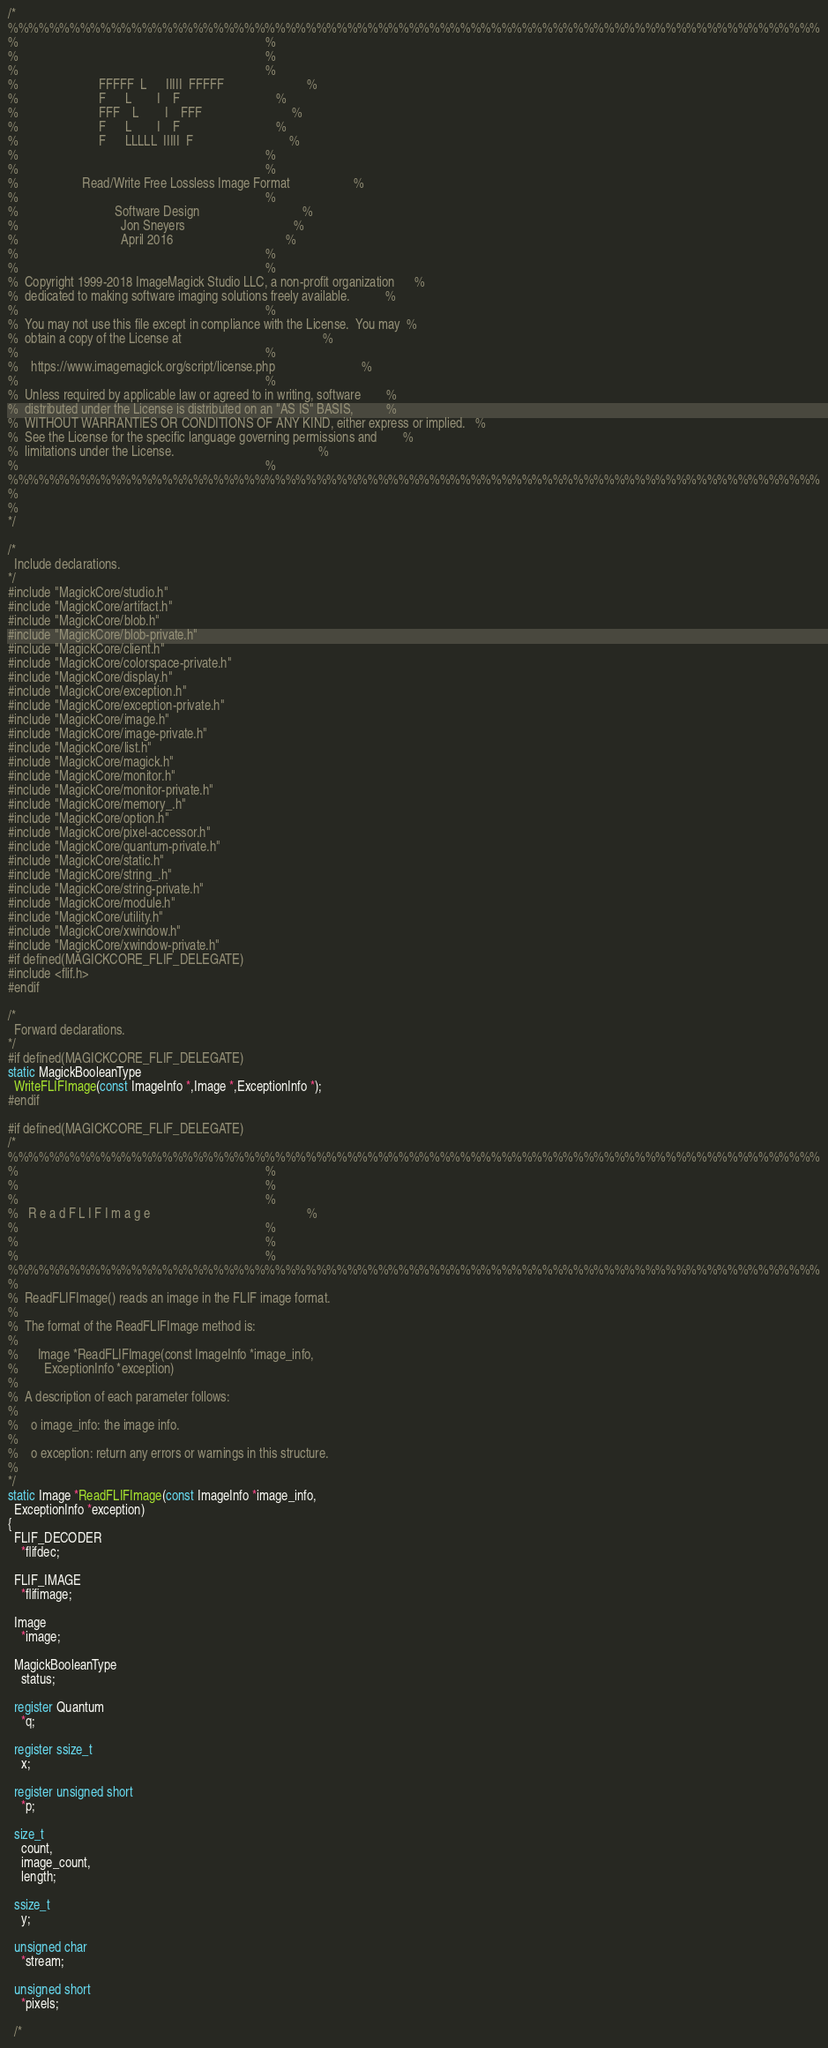<code> <loc_0><loc_0><loc_500><loc_500><_C_>/*
%%%%%%%%%%%%%%%%%%%%%%%%%%%%%%%%%%%%%%%%%%%%%%%%%%%%%%%%%%%%%%%%%%%%%%%%%%%%%%%
%                                                                             %
%                                                                             %
%                                                                             %
%                         FFFFF  L      IIIII  FFFFF                          %
%                         F      L        I    F                              %
%                         FFF    L        I    FFF                            %
%                         F      L        I    F                              %
%                         F      LLLLL  IIIII  F                              %
%                                                                             %
%                                                                             %
%                    Read/Write Free Lossless Image Format                    %
%                                                                             %
%                              Software Design                                %
%                                Jon Sneyers                                  %
%                                April 2016                                   %
%                                                                             %
%                                                                             %
%  Copyright 1999-2018 ImageMagick Studio LLC, a non-profit organization      %
%  dedicated to making software imaging solutions freely available.           %
%                                                                             %
%  You may not use this file except in compliance with the License.  You may  %
%  obtain a copy of the License at                                            %
%                                                                             %
%    https://www.imagemagick.org/script/license.php                           %
%                                                                             %
%  Unless required by applicable law or agreed to in writing, software        %
%  distributed under the License is distributed on an "AS IS" BASIS,          %
%  WITHOUT WARRANTIES OR CONDITIONS OF ANY KIND, either express or implied.   %
%  See the License for the specific language governing permissions and        %
%  limitations under the License.                                             %
%                                                                             %
%%%%%%%%%%%%%%%%%%%%%%%%%%%%%%%%%%%%%%%%%%%%%%%%%%%%%%%%%%%%%%%%%%%%%%%%%%%%%%%
%
%
*/

/*
  Include declarations.
*/
#include "MagickCore/studio.h"
#include "MagickCore/artifact.h"
#include "MagickCore/blob.h"
#include "MagickCore/blob-private.h"
#include "MagickCore/client.h"
#include "MagickCore/colorspace-private.h"
#include "MagickCore/display.h"
#include "MagickCore/exception.h"
#include "MagickCore/exception-private.h"
#include "MagickCore/image.h"
#include "MagickCore/image-private.h"
#include "MagickCore/list.h"
#include "MagickCore/magick.h"
#include "MagickCore/monitor.h"
#include "MagickCore/monitor-private.h"
#include "MagickCore/memory_.h"
#include "MagickCore/option.h"
#include "MagickCore/pixel-accessor.h"
#include "MagickCore/quantum-private.h"
#include "MagickCore/static.h"
#include "MagickCore/string_.h"
#include "MagickCore/string-private.h"
#include "MagickCore/module.h"
#include "MagickCore/utility.h"
#include "MagickCore/xwindow.h"
#include "MagickCore/xwindow-private.h"
#if defined(MAGICKCORE_FLIF_DELEGATE)
#include <flif.h>
#endif

/*
  Forward declarations.
*/
#if defined(MAGICKCORE_FLIF_DELEGATE)
static MagickBooleanType
  WriteFLIFImage(const ImageInfo *,Image *,ExceptionInfo *);
#endif

#if defined(MAGICKCORE_FLIF_DELEGATE)
/*
%%%%%%%%%%%%%%%%%%%%%%%%%%%%%%%%%%%%%%%%%%%%%%%%%%%%%%%%%%%%%%%%%%%%%%%%%%%%%%%
%                                                                             %
%                                                                             %
%                                                                             %
%   R e a d F L I F I m a g e                                                 %
%                                                                             %
%                                                                             %
%                                                                             %
%%%%%%%%%%%%%%%%%%%%%%%%%%%%%%%%%%%%%%%%%%%%%%%%%%%%%%%%%%%%%%%%%%%%%%%%%%%%%%%
%
%  ReadFLIFImage() reads an image in the FLIF image format.
%
%  The format of the ReadFLIFImage method is:
%
%      Image *ReadFLIFImage(const ImageInfo *image_info,
%        ExceptionInfo *exception)
%
%  A description of each parameter follows:
%
%    o image_info: the image info.
%
%    o exception: return any errors or warnings in this structure.
%
*/
static Image *ReadFLIFImage(const ImageInfo *image_info,
  ExceptionInfo *exception)
{
  FLIF_DECODER
    *flifdec;

  FLIF_IMAGE
    *flifimage;

  Image
    *image;

  MagickBooleanType
    status;

  register Quantum
    *q;

  register ssize_t
    x;

  register unsigned short
    *p;

  size_t
    count,
    image_count,
    length;

  ssize_t
    y;

  unsigned char
    *stream;

  unsigned short
    *pixels;

  /*</code> 